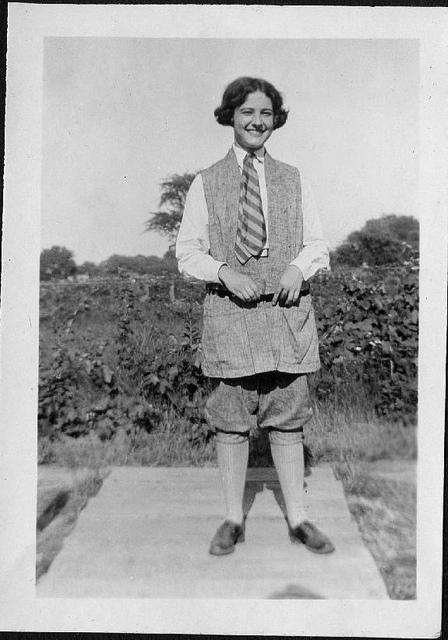What sport is the woman playing?
Answer briefly. Tennis. Is the image old?
Give a very brief answer. Yes. Does the person have on blue jeans?
Answer briefly. No. Is the woman wearing a coat?
Write a very short answer. No. What is the woman on the middle right carrying?
Write a very short answer. Purse. What is the girl wearing?
Be succinct. Tie. Is this person wearing a tie?
Answer briefly. Yes. How many people are wearing ties?
Write a very short answer. 1. Is she dancing?
Short answer required. No. How do you think the person feels who threw the ball?
Write a very short answer. Happy. What length is this person's hair?
Answer briefly. Short. Is this person a historic figure?
Short answer required. No. Is this a current era photo?
Short answer required. No. Is the woman happy?
Be succinct. Yes. What is the woman wearing?
Short answer required. Shorts. Is she carrying a purse?
Answer briefly. No. Is there someone standing in the background?
Write a very short answer. No. What is the woman doing?
Keep it brief. Standing. Is the person wearing a hat?
Write a very short answer. No. 